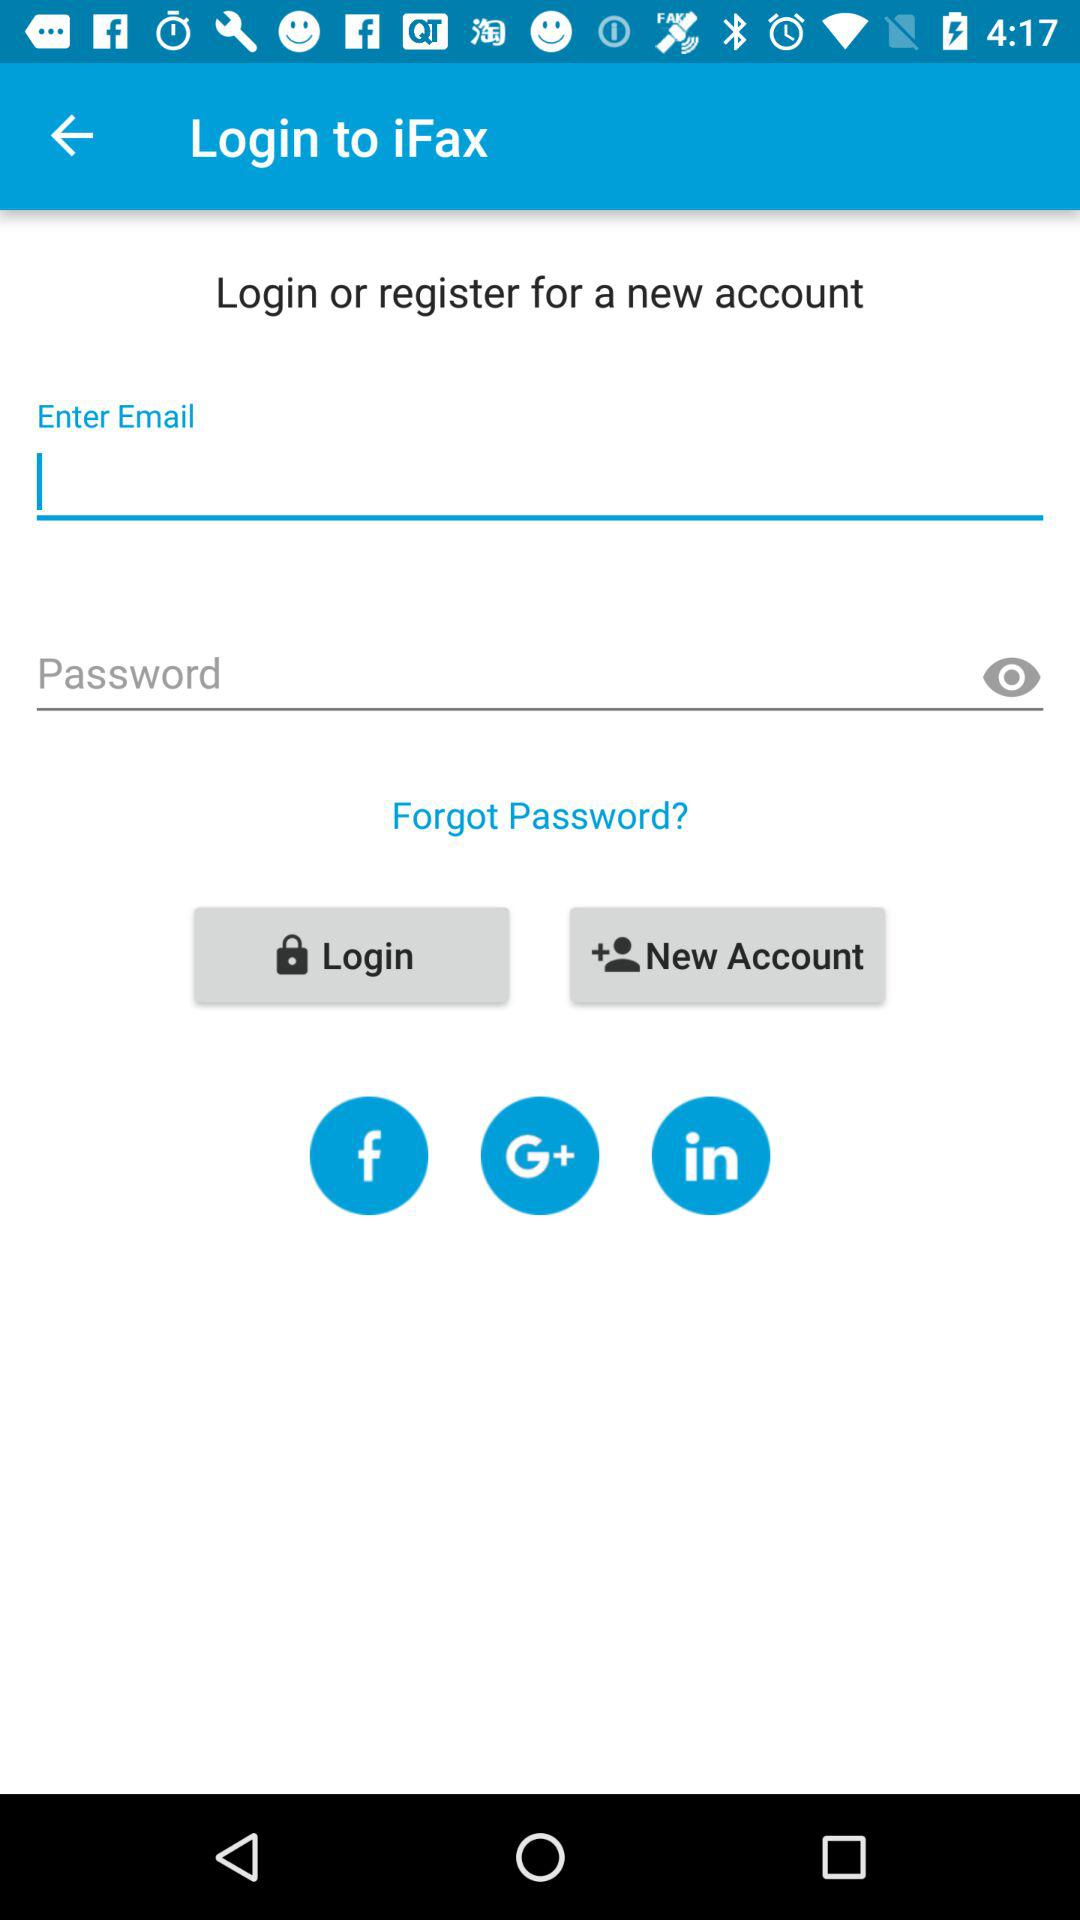What accounts can we use to log in? You can log in with "Facebook", "Google+", "LinkedIn" and "Email". 